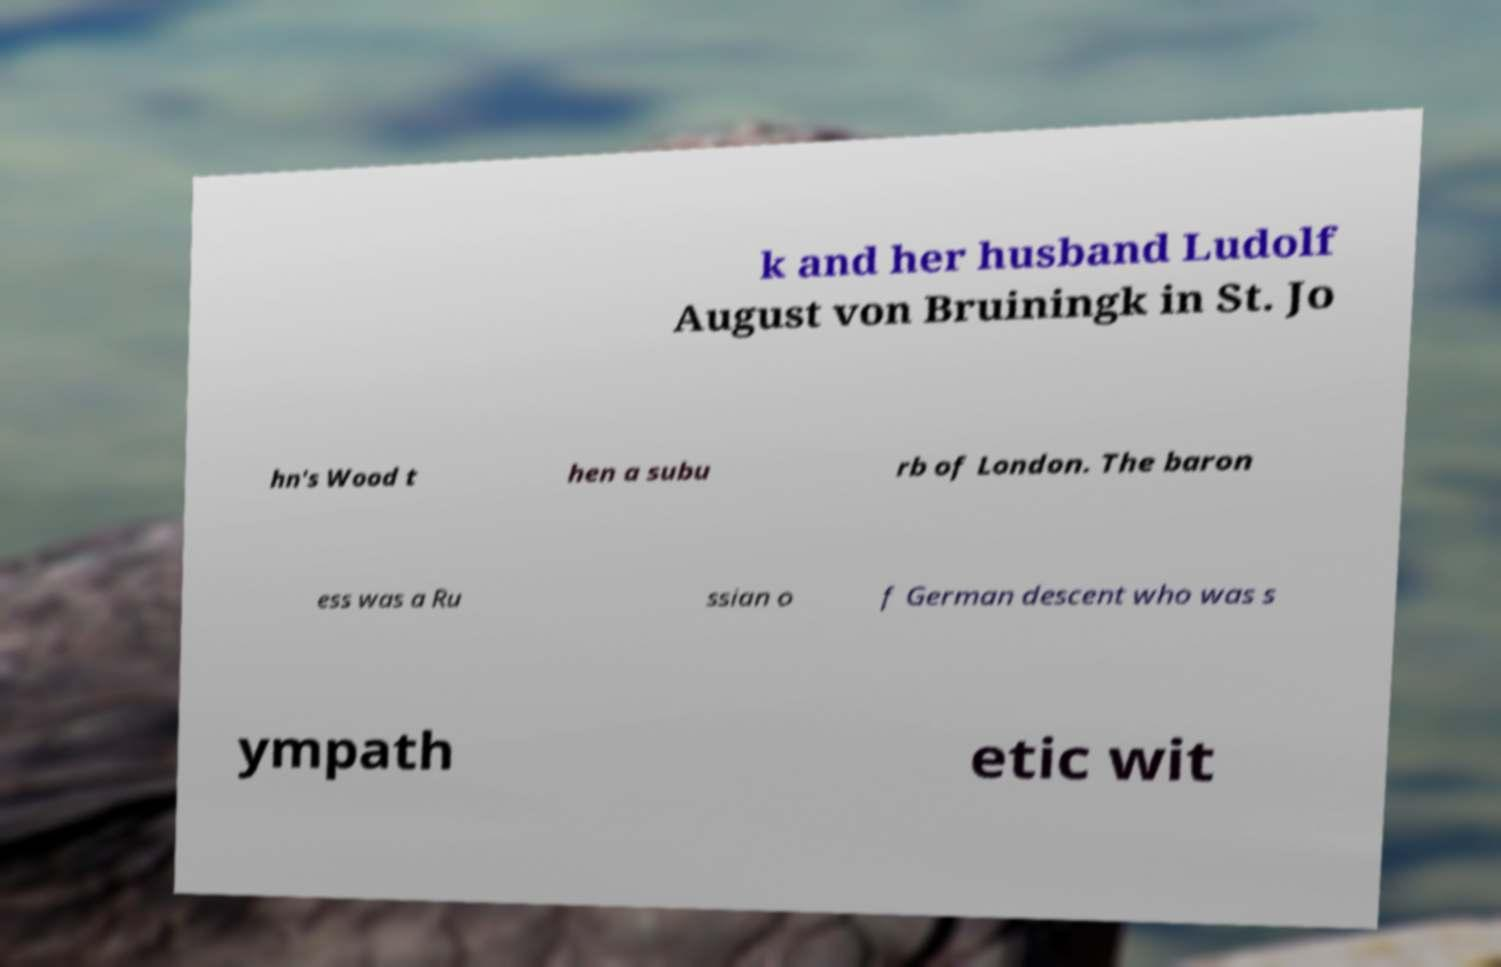Can you accurately transcribe the text from the provided image for me? k and her husband Ludolf August von Bruiningk in St. Jo hn's Wood t hen a subu rb of London. The baron ess was a Ru ssian o f German descent who was s ympath etic wit 